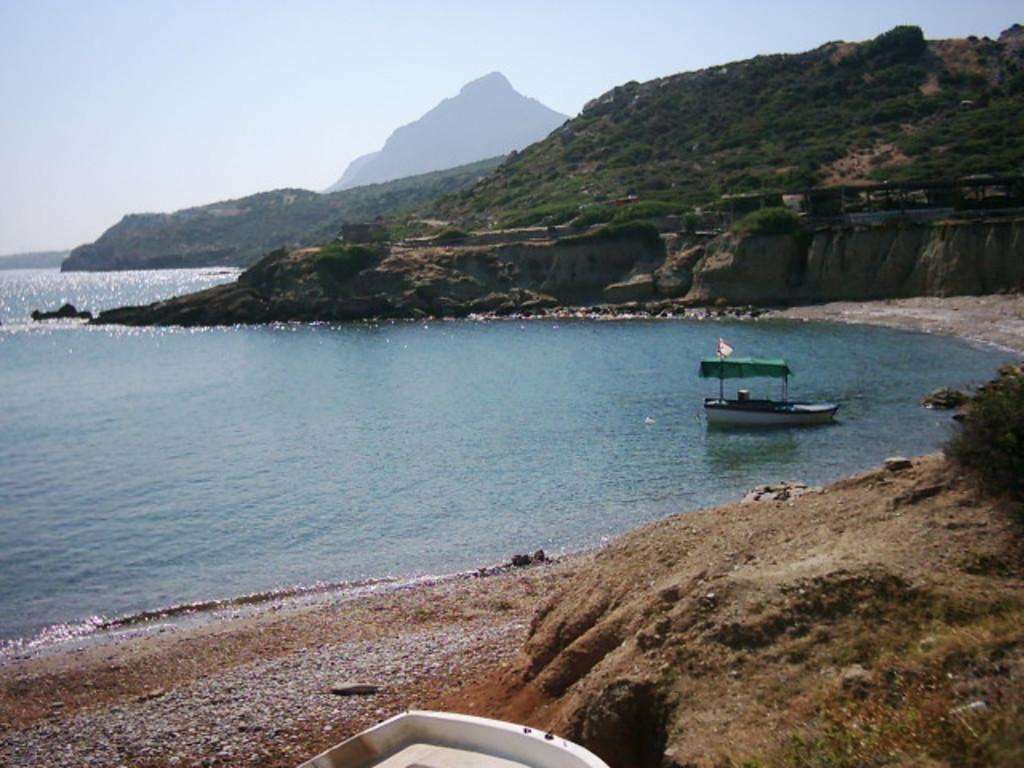How would you summarize this image in a sentence or two? In this picture there is water in the center of the image and there are mountains on the right side of the image, there is boat on the water on the right side of the image. 